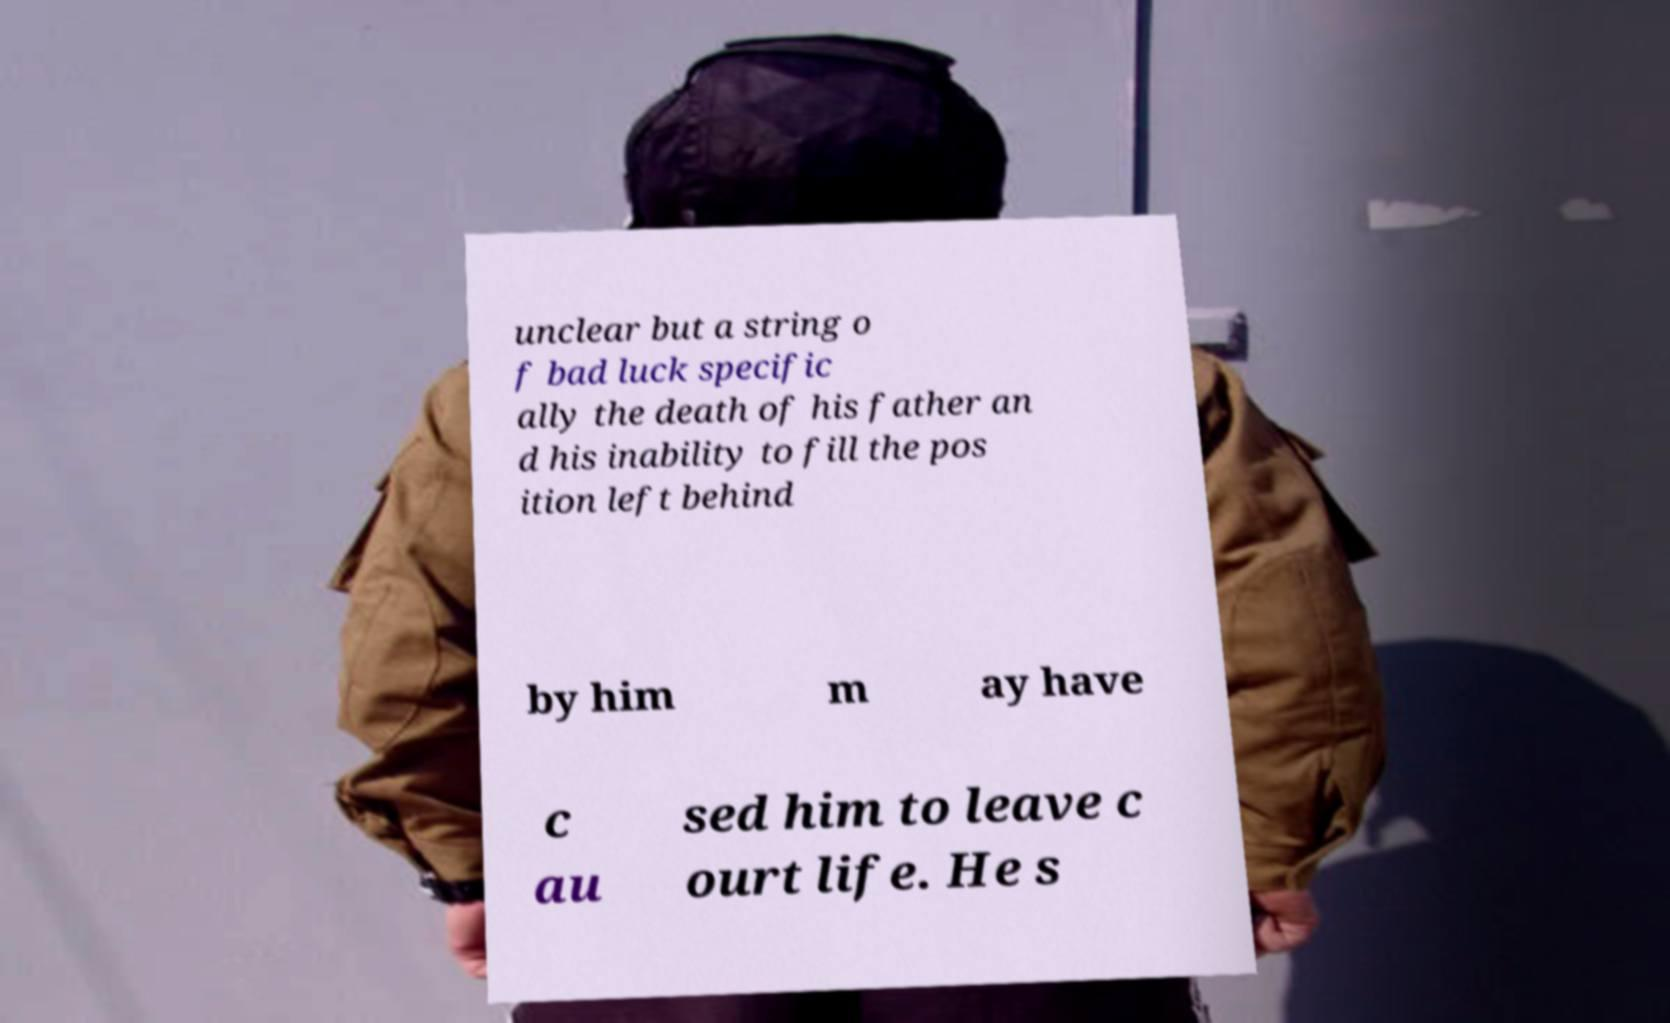Could you assist in decoding the text presented in this image and type it out clearly? unclear but a string o f bad luck specific ally the death of his father an d his inability to fill the pos ition left behind by him m ay have c au sed him to leave c ourt life. He s 